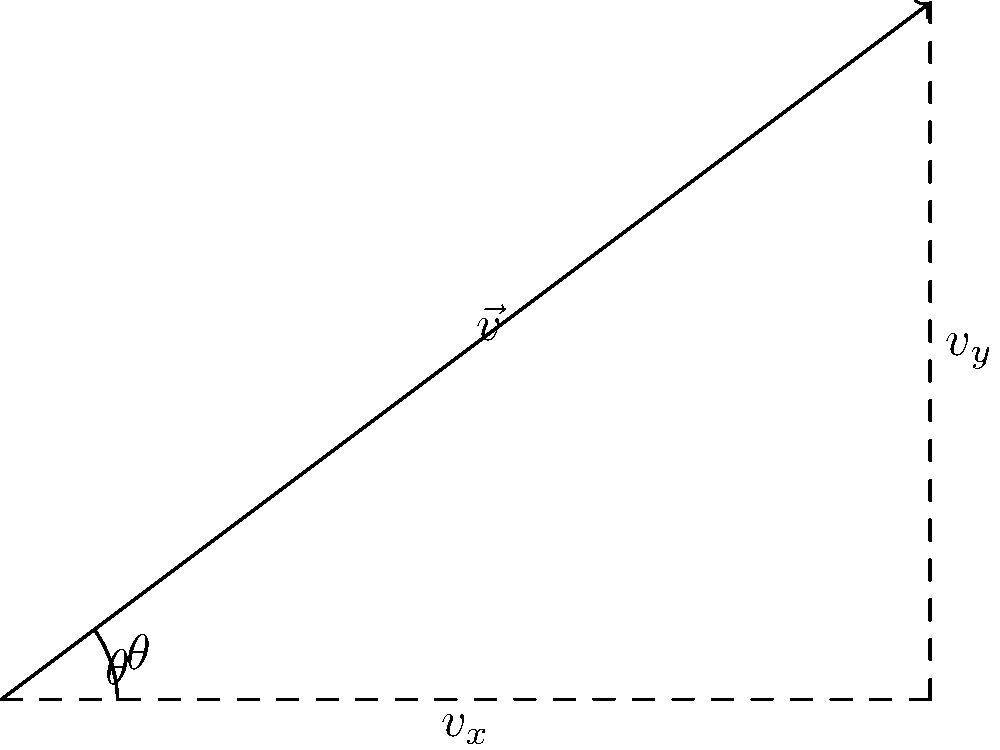In our physics lab at Chapman University, we're analyzing projectile motion. A ball is launched with an initial velocity vector $\vec{v}$ as shown in the diagram. The magnitude of $\vec{v}$ is 5 m/s, and it makes an angle $\theta = 36.87°$ with the horizontal. Calculate the horizontal ($v_x$) and vertical ($v_y$) components of the velocity vector. To solve this problem, we'll use the trigonometric relationships for decomposing a vector into its components:

1) For the horizontal component $v_x$:
   $v_x = |\vec{v}| \cos(\theta)$

2) For the vertical component $v_y$:
   $v_y = |\vec{v}| \sin(\theta)$

Given:
- $|\vec{v}| = 5$ m/s
- $\theta = 36.87°$

Calculations:
1) $v_x = 5 \cos(36.87°) = 5 \cdot 0.8 = 4$ m/s

2) $v_y = 5 \sin(36.87°) = 5 \cdot 0.6 = 3$ m/s

Therefore, the horizontal component $v_x$ is 4 m/s, and the vertical component $v_y$ is 3 m/s.
Answer: $v_x = 4$ m/s, $v_y = 3$ m/s 